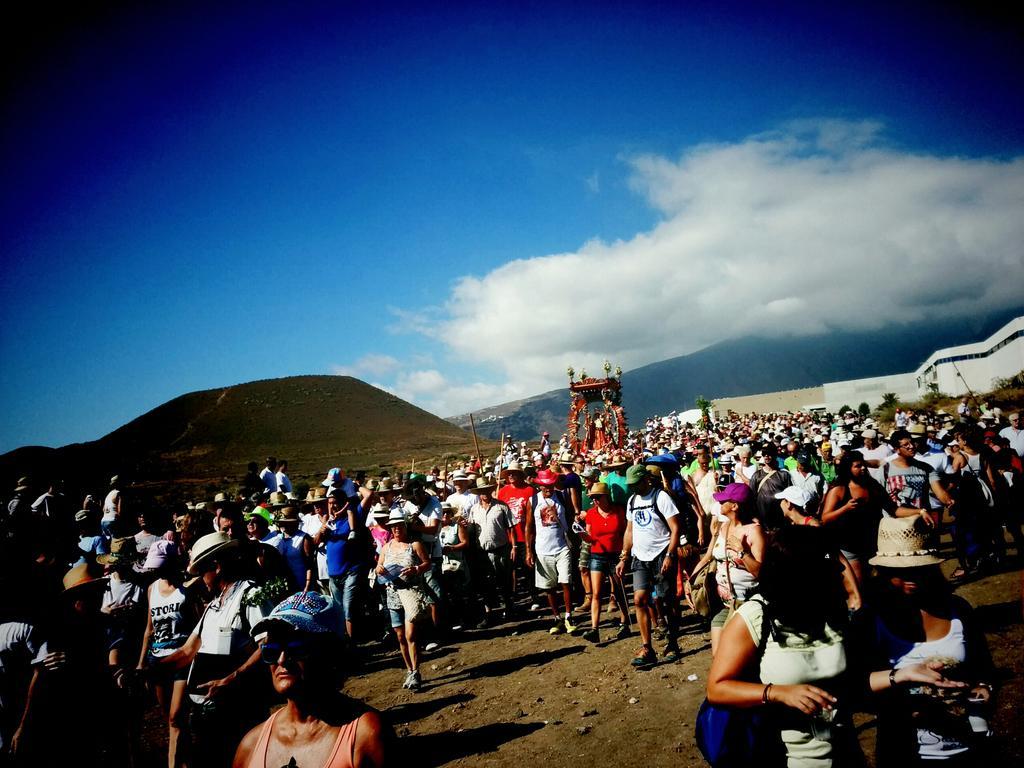Can you describe this image briefly? In this image I can see group of people some are standing and someone walking, background I can see the red color object and I can see the grass in green color and the sky is in blue and white color. 